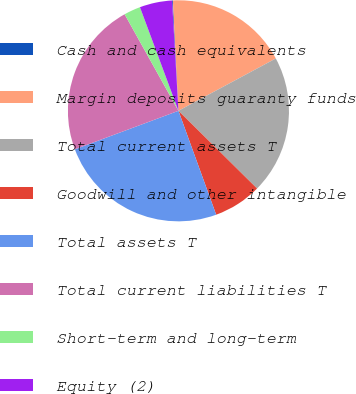Convert chart to OTSL. <chart><loc_0><loc_0><loc_500><loc_500><pie_chart><fcel>Cash and cash equivalents<fcel>Margin deposits guaranty funds<fcel>Total current assets T<fcel>Goodwill and other intangible<fcel>Total assets T<fcel>Total current liabilities T<fcel>Short-term and long-term<fcel>Equity (2)<nl><fcel>0.12%<fcel>17.95%<fcel>20.26%<fcel>7.05%<fcel>24.88%<fcel>22.57%<fcel>2.43%<fcel>4.74%<nl></chart> 